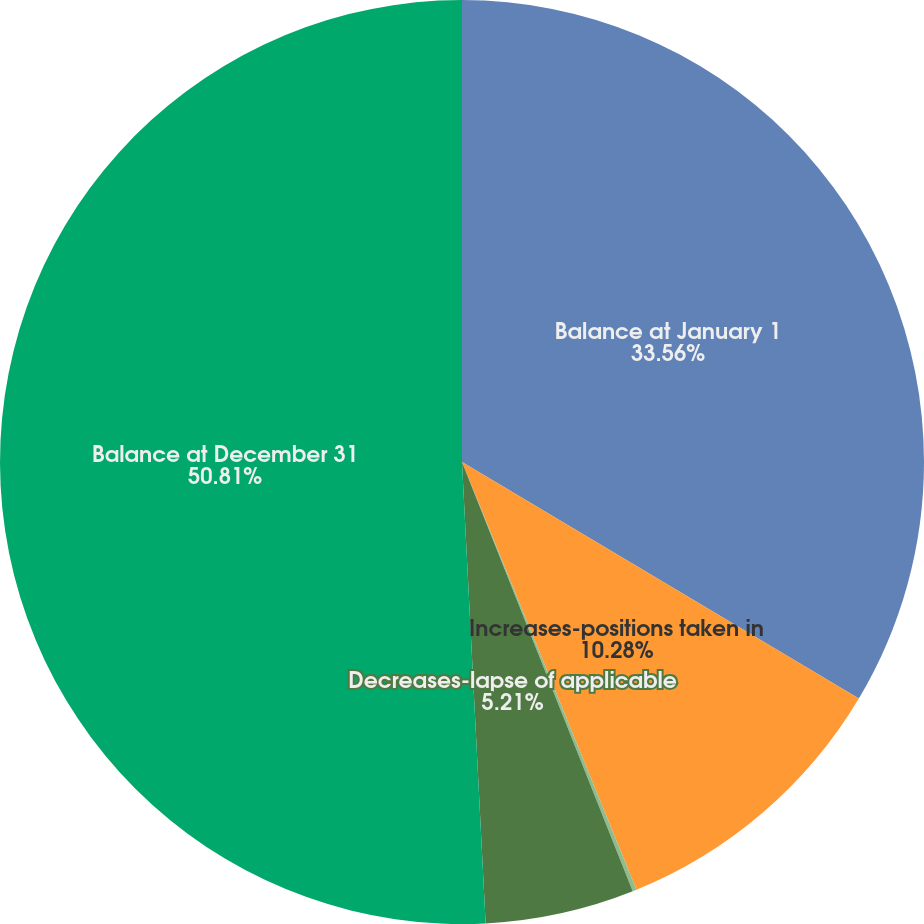Convert chart to OTSL. <chart><loc_0><loc_0><loc_500><loc_500><pie_chart><fcel>Balance at January 1<fcel>Increases-positions taken in<fcel>Decreases-settlements with<fcel>Decreases-lapse of applicable<fcel>Balance at December 31<nl><fcel>33.56%<fcel>10.28%<fcel>0.14%<fcel>5.21%<fcel>50.82%<nl></chart> 